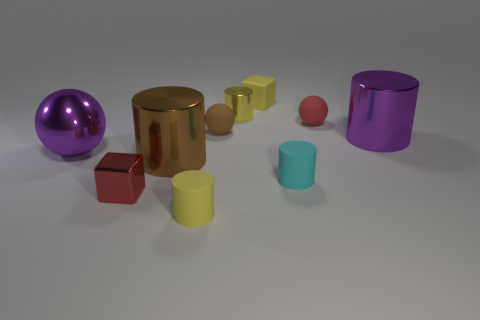Subtract all brown cylinders. How many cylinders are left? 4 Subtract all tiny yellow shiny cylinders. How many cylinders are left? 4 Subtract all brown cylinders. Subtract all red balls. How many cylinders are left? 4 Subtract all spheres. How many objects are left? 7 Add 8 brown cylinders. How many brown cylinders exist? 9 Subtract 0 blue spheres. How many objects are left? 10 Subtract all tiny gray things. Subtract all small matte balls. How many objects are left? 8 Add 6 tiny cyan rubber cylinders. How many tiny cyan rubber cylinders are left? 7 